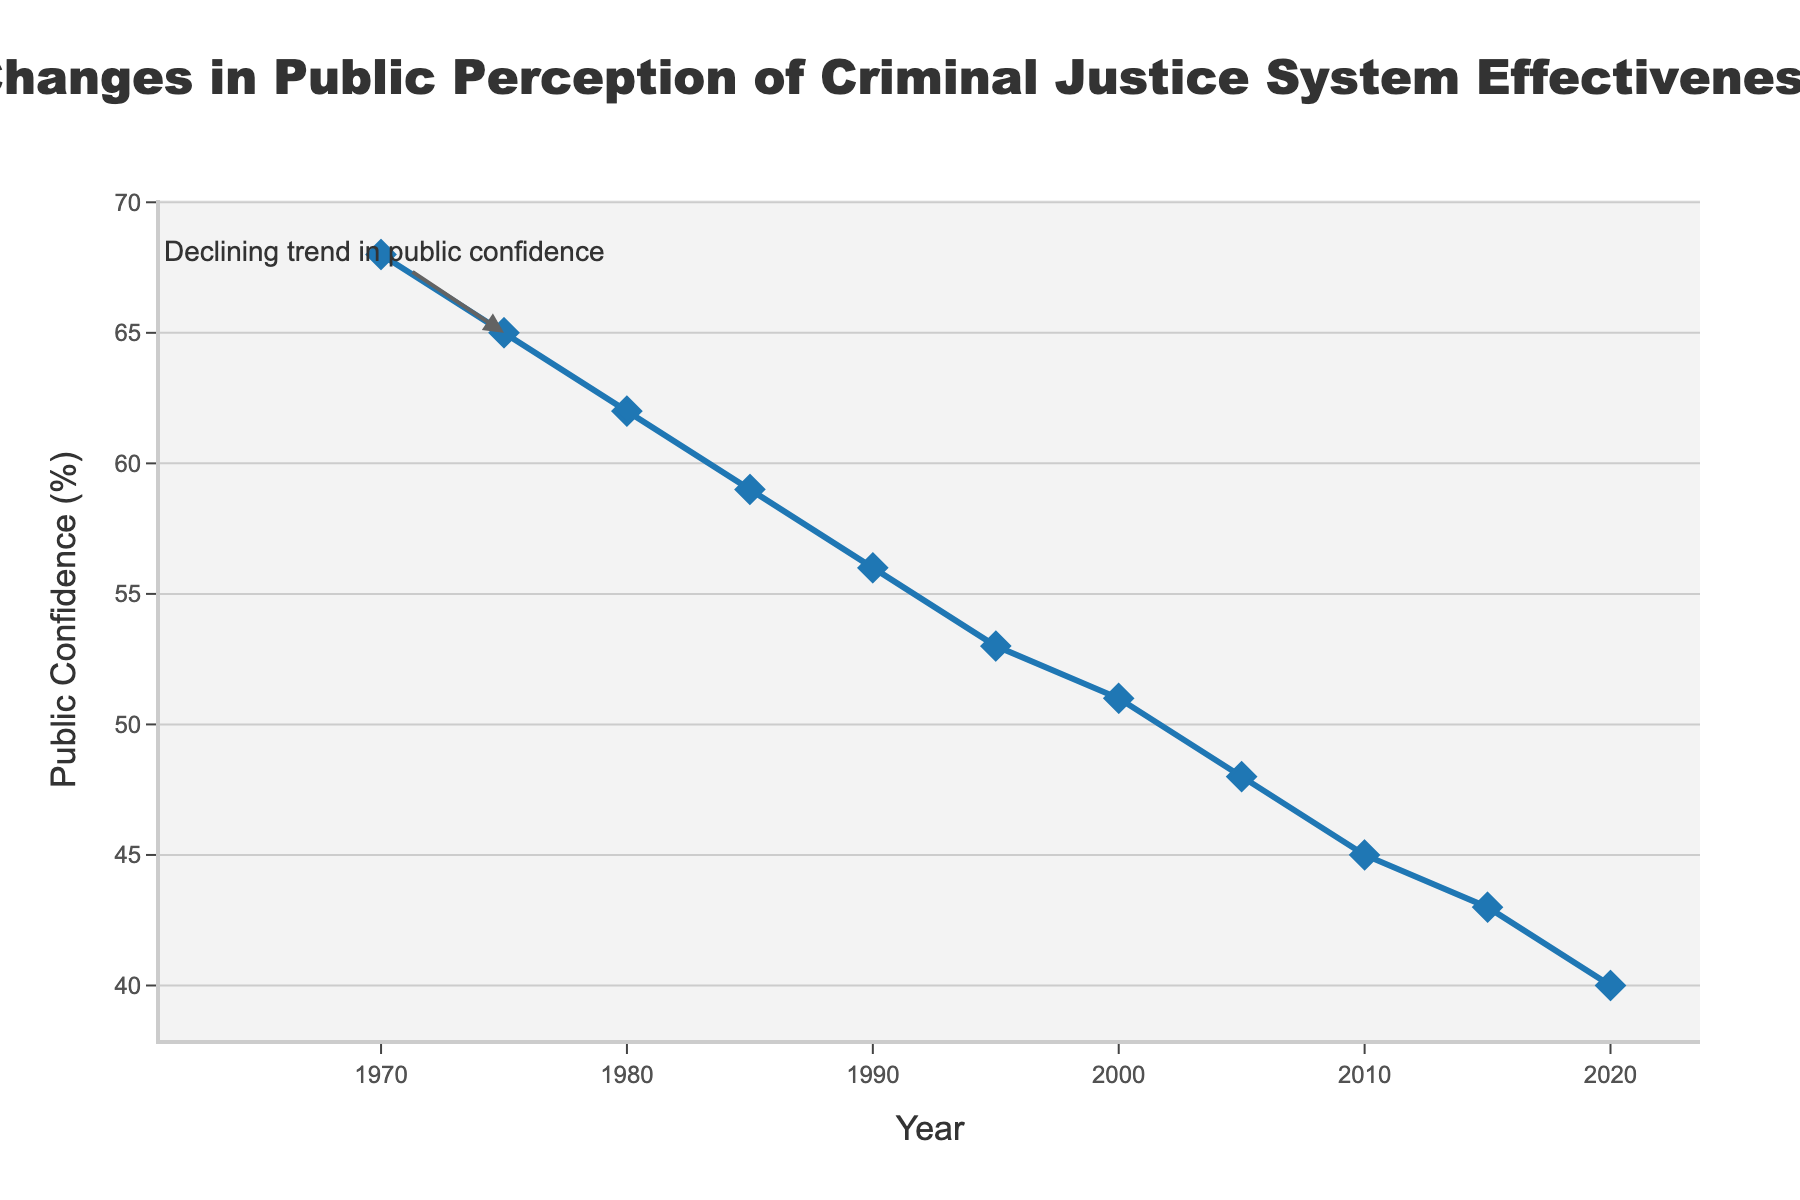what is the general trend in public confidence in the criminal justice system from 1970 to 2020? The graph shows a decline in the percentage of public confidence over the 50-year period, starting from 68% in 1970 and dropping to 40% in 2020.
Answer: Declining How much did public confidence decline between 1970 and 1990? Public confidence was 68% in 1970 and dropped to 56% in 1990. The difference is 68 - 56 = 12%.
Answer: 12% In which decade did public confidence fall the most sharply? By observing the slopes in each decade on the graph, the steepest decline appears between 2000 and 2010, where it fell from 51% to 45%, a 6% decrease.
Answer: 2000-2010 What was the public confidence in the criminal justice system in 1995? On the graph at the point for the year 1995, the percentage of public confidence is 53%.
Answer: 53% Between which two consecutive points on the timeline was the smallest decrease in public confidence observed? By examining the graph points, the smallest decrease is noted between 2015 (43%) and 2020 (40%), with a difference of 3%.
Answer: 2015 and 2020 What is the average public confidence over the given years? Sum the confidence percentages: 68 + 65 + 62 + 59 + 56 + 53 + 51 + 48 + 45 + 43 + 40 = 590. Divide by the number of years (11): 590 / 11 ≈ 53.64%.
Answer: 53.64% If the trend continues, what might be the estimated public confidence in 2025? The trend shows a consistent decrease over decades. If public confidence decreased by about 5% every 5 years recently, then from 40% in 2020 it might be around 35% in 2025.
Answer: 35% Which year had a higher public confidence in the criminal justice system, 1985 or 2005? Observing the graph, 1985 had 59% confidence while 2005 had 48% confidence. 1985 had higher confidence.
Answer: 1985 Is there a point on the graph where the public confidence remained the same across two consecutive years? Reviewing the graph, all adjacent data points exhibit a decline. No point shows constant confidence across two consecutive years.
Answer: No 